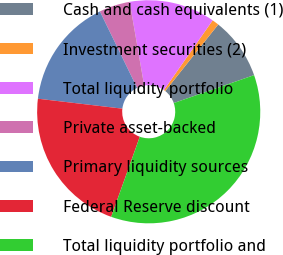Convert chart to OTSL. <chart><loc_0><loc_0><loc_500><loc_500><pie_chart><fcel>Cash and cash equivalents (1)<fcel>Investment securities (2)<fcel>Total liquidity portfolio<fcel>Private asset-backed<fcel>Primary liquidity sources<fcel>Federal Reserve discount<fcel>Total liquidity portfolio and<nl><fcel>8.97%<fcel>0.99%<fcel>12.45%<fcel>4.47%<fcel>15.93%<fcel>21.41%<fcel>35.78%<nl></chart> 